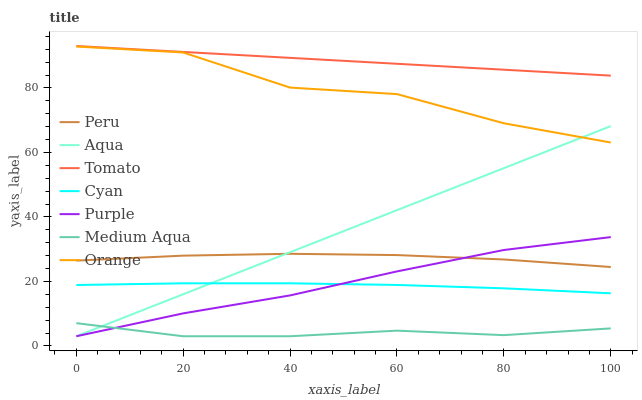Does Medium Aqua have the minimum area under the curve?
Answer yes or no. Yes. Does Tomato have the maximum area under the curve?
Answer yes or no. Yes. Does Purple have the minimum area under the curve?
Answer yes or no. No. Does Purple have the maximum area under the curve?
Answer yes or no. No. Is Aqua the smoothest?
Answer yes or no. Yes. Is Orange the roughest?
Answer yes or no. Yes. Is Purple the smoothest?
Answer yes or no. No. Is Purple the roughest?
Answer yes or no. No. Does Purple have the lowest value?
Answer yes or no. Yes. Does Peru have the lowest value?
Answer yes or no. No. Does Tomato have the highest value?
Answer yes or no. Yes. Does Purple have the highest value?
Answer yes or no. No. Is Medium Aqua less than Cyan?
Answer yes or no. Yes. Is Orange greater than Cyan?
Answer yes or no. Yes. Does Aqua intersect Medium Aqua?
Answer yes or no. Yes. Is Aqua less than Medium Aqua?
Answer yes or no. No. Is Aqua greater than Medium Aqua?
Answer yes or no. No. Does Medium Aqua intersect Cyan?
Answer yes or no. No. 